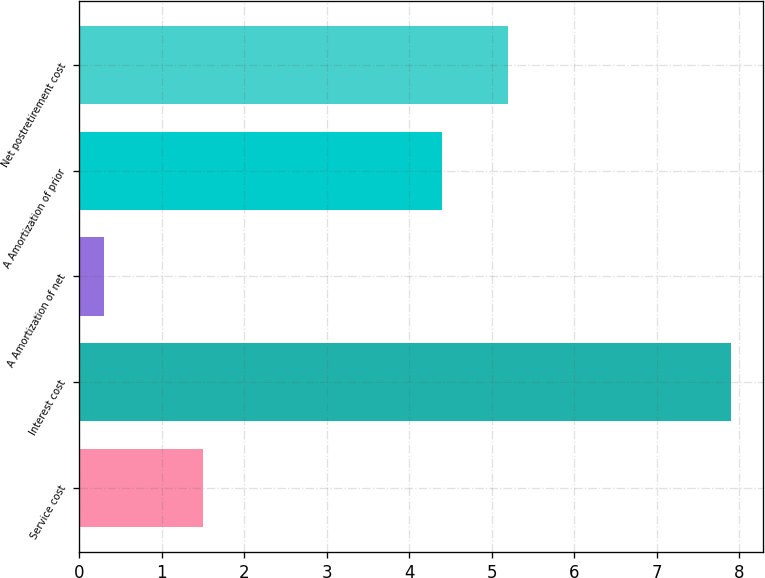<chart> <loc_0><loc_0><loc_500><loc_500><bar_chart><fcel>Service cost<fcel>Interest cost<fcel>A Amortization of net<fcel>A Amortization of prior<fcel>Net postretirement cost<nl><fcel>1.5<fcel>7.9<fcel>0.3<fcel>4.4<fcel>5.2<nl></chart> 